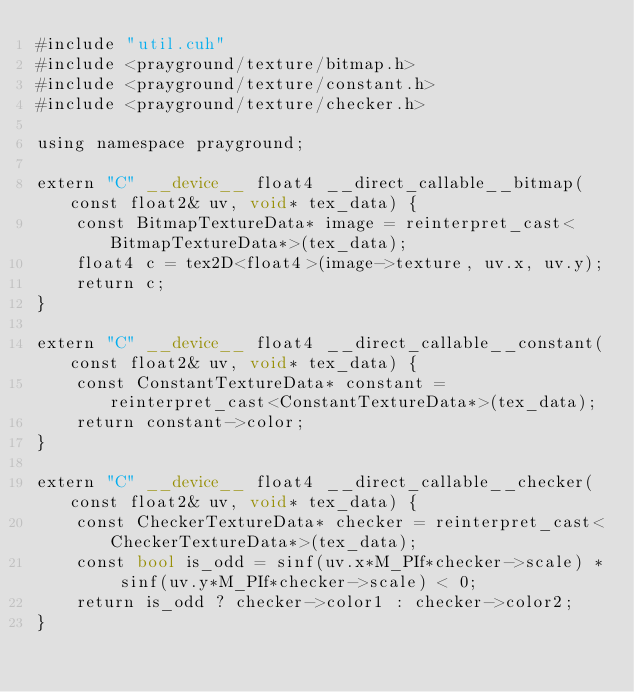<code> <loc_0><loc_0><loc_500><loc_500><_Cuda_>#include "util.cuh"
#include <prayground/texture/bitmap.h>
#include <prayground/texture/constant.h>
#include <prayground/texture/checker.h>

using namespace prayground;

extern "C" __device__ float4 __direct_callable__bitmap(const float2& uv, void* tex_data) {
    const BitmapTextureData* image = reinterpret_cast<BitmapTextureData*>(tex_data);
    float4 c = tex2D<float4>(image->texture, uv.x, uv.y);
    return c;
}

extern "C" __device__ float4 __direct_callable__constant(const float2& uv, void* tex_data) {
    const ConstantTextureData* constant = reinterpret_cast<ConstantTextureData*>(tex_data);
    return constant->color;
}

extern "C" __device__ float4 __direct_callable__checker(const float2& uv, void* tex_data) {
    const CheckerTextureData* checker = reinterpret_cast<CheckerTextureData*>(tex_data);
    const bool is_odd = sinf(uv.x*M_PIf*checker->scale) * sinf(uv.y*M_PIf*checker->scale) < 0;
    return is_odd ? checker->color1 : checker->color2;
}</code> 